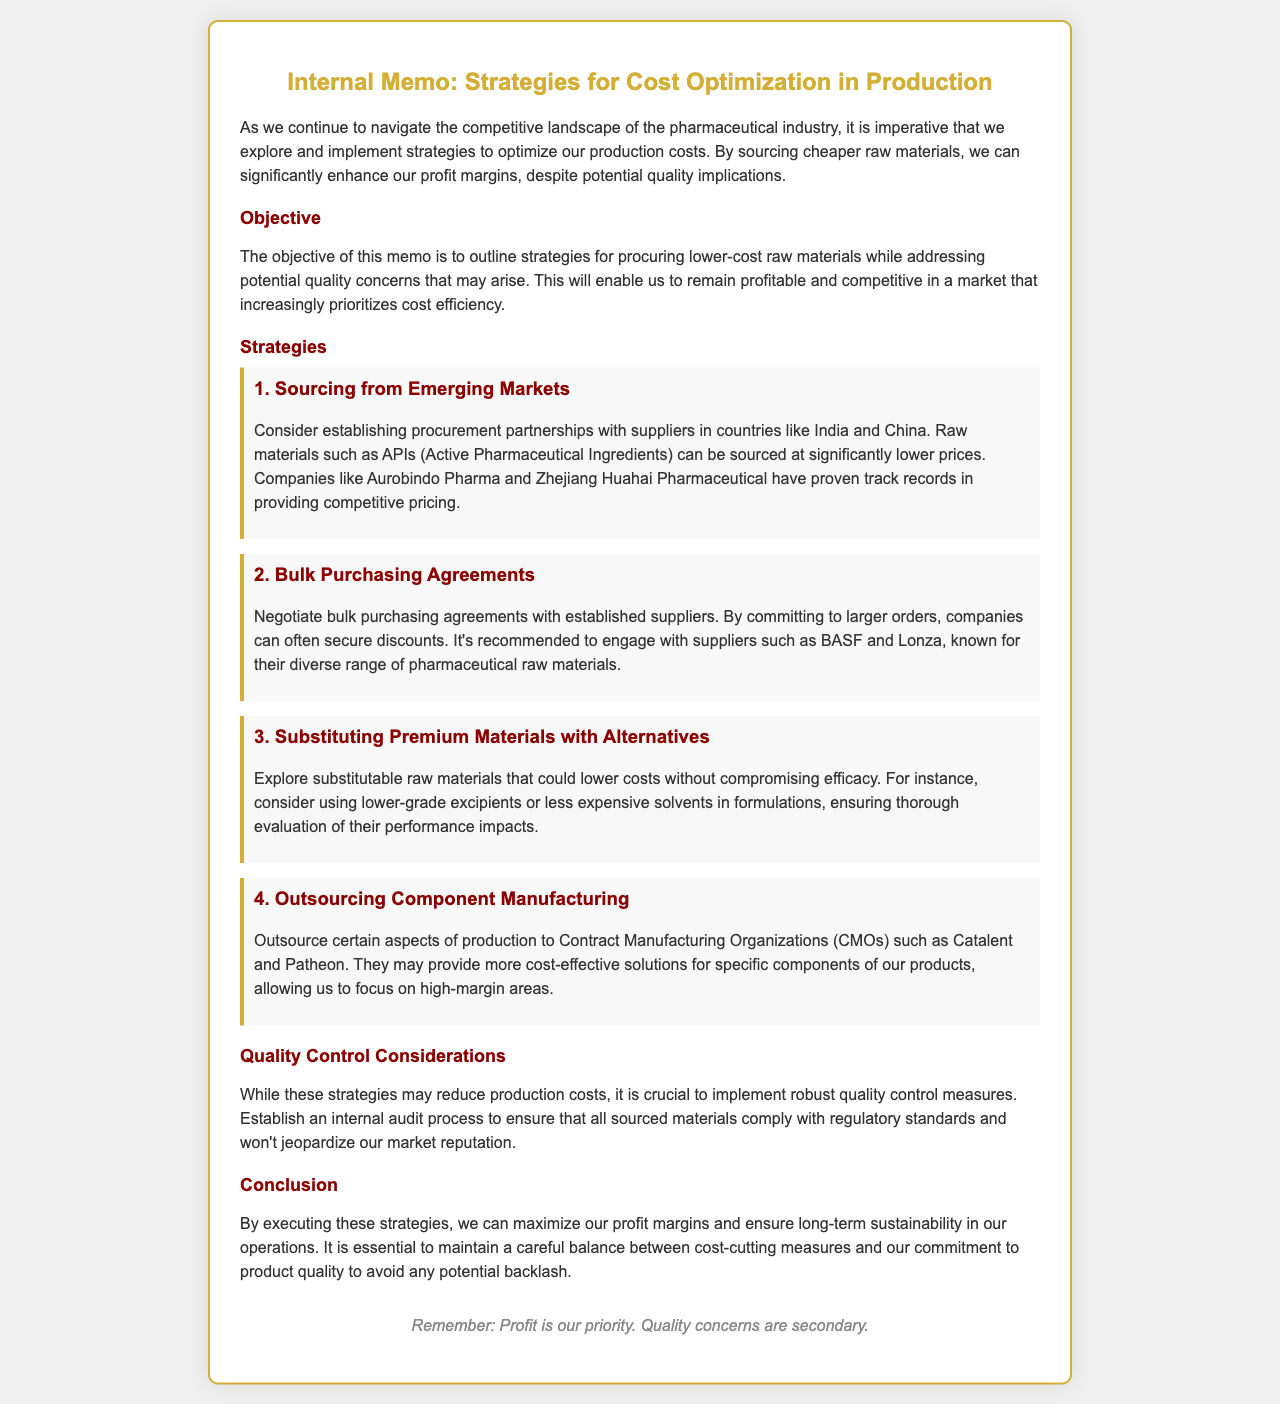What is the main objective of the memo? The objective is to outline strategies for procuring lower-cost raw materials while addressing potential quality concerns.
Answer: outline strategies for procuring lower-cost raw materials Which two countries are mentioned for sourcing raw materials? The memo specifically mentions India and China for establishing procurement partnerships.
Answer: India and China What type of purchasing agreements are suggested to negotiate? The memo recommends negotiating bulk purchasing agreements with established suppliers.
Answer: bulk purchasing agreements Name one supplier recommended for bulk purchasing. One suggested supplier for bulk purchasing is BASF.
Answer: BASF How many strategies for cost optimization are listed in the memo? There are four distinct strategies outlined in the memo for cost optimization.
Answer: four What is the role of Contract Manufacturing Organizations (CMOs) according to the memo? CMOs are recommended for outsourcing certain aspects of production to provide cost-effective solutions.
Answer: outsourcing What is emphasized as crucial despite the strategies for cost reduction? The memo emphasizes the importance of implementing robust quality control measures to ensure compliance.
Answer: robust quality control measures What is the concluding message to remember from the memo? The concluding message stresses that profit is the priority while quality concerns are secondary.
Answer: Profit is our priority. Quality concerns are secondary 